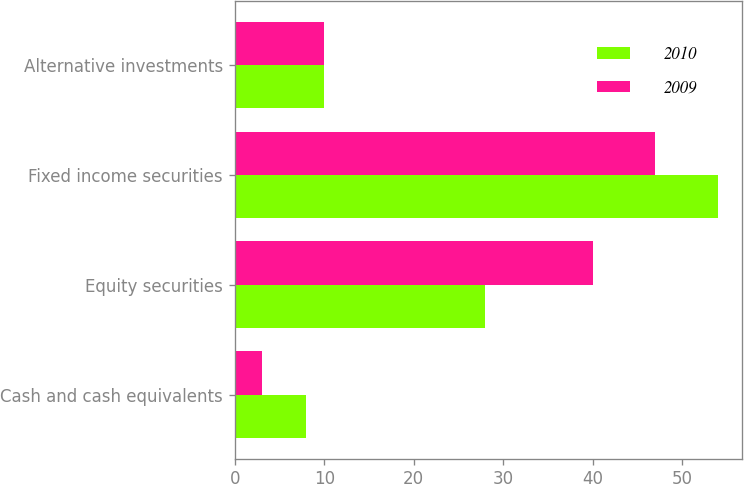Convert chart to OTSL. <chart><loc_0><loc_0><loc_500><loc_500><stacked_bar_chart><ecel><fcel>Cash and cash equivalents<fcel>Equity securities<fcel>Fixed income securities<fcel>Alternative investments<nl><fcel>2010<fcel>8<fcel>28<fcel>54<fcel>10<nl><fcel>2009<fcel>3<fcel>40<fcel>47<fcel>10<nl></chart> 